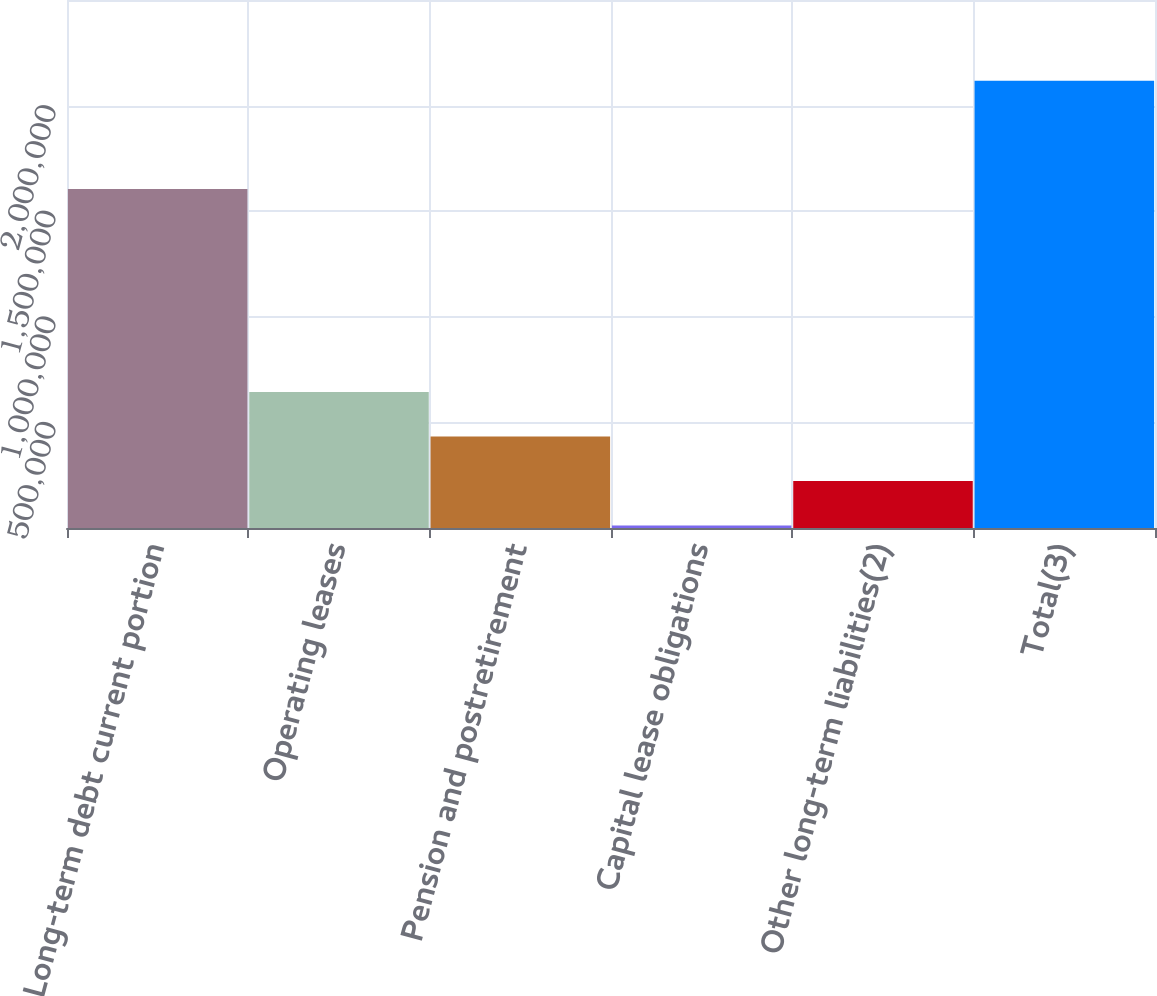Convert chart to OTSL. <chart><loc_0><loc_0><loc_500><loc_500><bar_chart><fcel>Long-term debt current portion<fcel>Operating leases<fcel>Pension and postretirement<fcel>Capital lease obligations<fcel>Other long-term liabilities(2)<fcel>Total(3)<nl><fcel>1.60526e+06<fcel>643433<fcel>432784<fcel>11487<fcel>222136<fcel>2.11797e+06<nl></chart> 